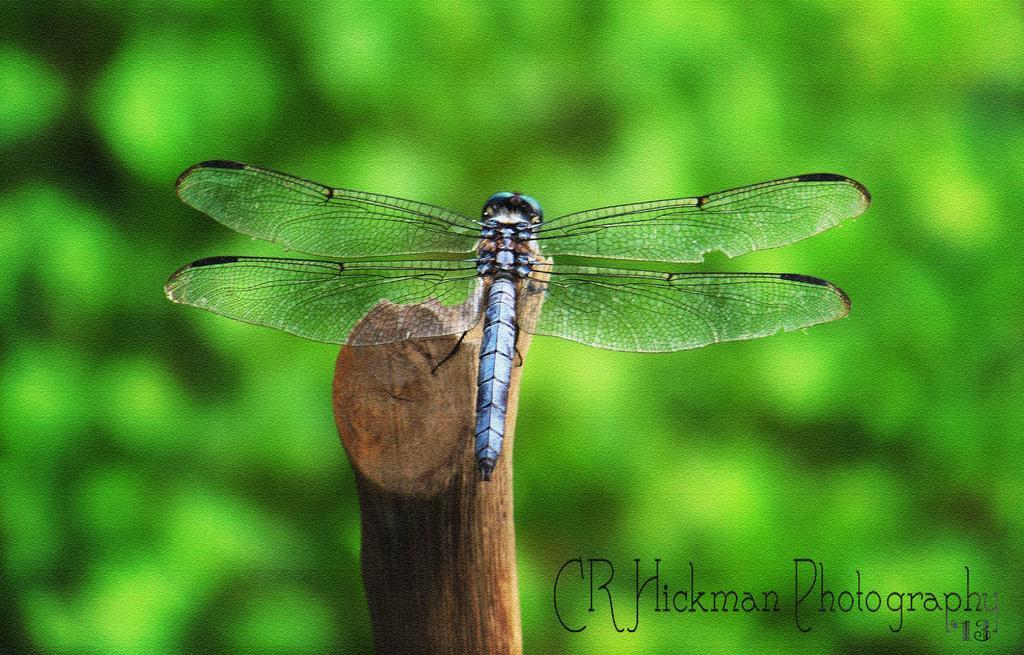Please provide a concise description of this image. In this image we can see a dragonfly on the wooden stick. 